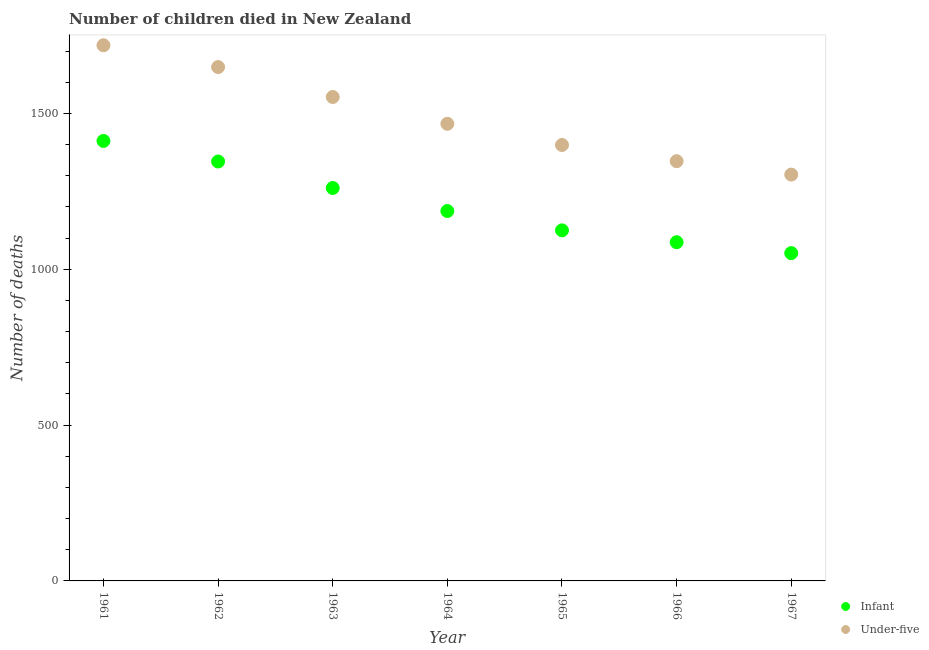How many different coloured dotlines are there?
Offer a very short reply. 2. What is the number of under-five deaths in 1964?
Your answer should be very brief. 1467. Across all years, what is the maximum number of under-five deaths?
Provide a short and direct response. 1719. Across all years, what is the minimum number of under-five deaths?
Your answer should be compact. 1304. In which year was the number of infant deaths maximum?
Give a very brief answer. 1961. In which year was the number of infant deaths minimum?
Offer a terse response. 1967. What is the total number of under-five deaths in the graph?
Give a very brief answer. 1.04e+04. What is the difference between the number of infant deaths in 1966 and that in 1967?
Your response must be concise. 35. What is the difference between the number of under-five deaths in 1967 and the number of infant deaths in 1961?
Your answer should be compact. -108. What is the average number of under-five deaths per year?
Your response must be concise. 1491.14. In the year 1967, what is the difference between the number of infant deaths and number of under-five deaths?
Your response must be concise. -252. What is the ratio of the number of under-five deaths in 1963 to that in 1966?
Provide a short and direct response. 1.15. Is the number of infant deaths in 1962 less than that in 1965?
Offer a very short reply. No. Is the difference between the number of infant deaths in 1964 and 1965 greater than the difference between the number of under-five deaths in 1964 and 1965?
Offer a terse response. No. What is the difference between the highest and the second highest number of infant deaths?
Make the answer very short. 66. What is the difference between the highest and the lowest number of under-five deaths?
Give a very brief answer. 415. Is the sum of the number of infant deaths in 1962 and 1963 greater than the maximum number of under-five deaths across all years?
Keep it short and to the point. Yes. Does the number of infant deaths monotonically increase over the years?
Ensure brevity in your answer.  No. Is the number of under-five deaths strictly less than the number of infant deaths over the years?
Keep it short and to the point. No. How many dotlines are there?
Your response must be concise. 2. How many years are there in the graph?
Ensure brevity in your answer.  7. What is the difference between two consecutive major ticks on the Y-axis?
Your response must be concise. 500. Are the values on the major ticks of Y-axis written in scientific E-notation?
Make the answer very short. No. Does the graph contain any zero values?
Ensure brevity in your answer.  No. How many legend labels are there?
Your response must be concise. 2. How are the legend labels stacked?
Offer a terse response. Vertical. What is the title of the graph?
Your answer should be very brief. Number of children died in New Zealand. What is the label or title of the Y-axis?
Your answer should be compact. Number of deaths. What is the Number of deaths of Infant in 1961?
Provide a short and direct response. 1412. What is the Number of deaths of Under-five in 1961?
Give a very brief answer. 1719. What is the Number of deaths of Infant in 1962?
Provide a succinct answer. 1346. What is the Number of deaths in Under-five in 1962?
Your answer should be very brief. 1649. What is the Number of deaths of Infant in 1963?
Your answer should be compact. 1261. What is the Number of deaths of Under-five in 1963?
Provide a succinct answer. 1553. What is the Number of deaths of Infant in 1964?
Keep it short and to the point. 1187. What is the Number of deaths in Under-five in 1964?
Give a very brief answer. 1467. What is the Number of deaths in Infant in 1965?
Provide a short and direct response. 1125. What is the Number of deaths in Under-five in 1965?
Give a very brief answer. 1399. What is the Number of deaths of Infant in 1966?
Keep it short and to the point. 1087. What is the Number of deaths of Under-five in 1966?
Keep it short and to the point. 1347. What is the Number of deaths of Infant in 1967?
Your answer should be very brief. 1052. What is the Number of deaths of Under-five in 1967?
Make the answer very short. 1304. Across all years, what is the maximum Number of deaths of Infant?
Provide a short and direct response. 1412. Across all years, what is the maximum Number of deaths of Under-five?
Your response must be concise. 1719. Across all years, what is the minimum Number of deaths in Infant?
Provide a short and direct response. 1052. Across all years, what is the minimum Number of deaths of Under-five?
Your answer should be very brief. 1304. What is the total Number of deaths of Infant in the graph?
Your answer should be very brief. 8470. What is the total Number of deaths in Under-five in the graph?
Your response must be concise. 1.04e+04. What is the difference between the Number of deaths of Infant in 1961 and that in 1962?
Make the answer very short. 66. What is the difference between the Number of deaths of Under-five in 1961 and that in 1962?
Your answer should be compact. 70. What is the difference between the Number of deaths in Infant in 1961 and that in 1963?
Provide a short and direct response. 151. What is the difference between the Number of deaths of Under-five in 1961 and that in 1963?
Give a very brief answer. 166. What is the difference between the Number of deaths in Infant in 1961 and that in 1964?
Offer a very short reply. 225. What is the difference between the Number of deaths in Under-five in 1961 and that in 1964?
Your answer should be very brief. 252. What is the difference between the Number of deaths in Infant in 1961 and that in 1965?
Your answer should be very brief. 287. What is the difference between the Number of deaths in Under-five in 1961 and that in 1965?
Provide a succinct answer. 320. What is the difference between the Number of deaths in Infant in 1961 and that in 1966?
Offer a very short reply. 325. What is the difference between the Number of deaths of Under-five in 1961 and that in 1966?
Keep it short and to the point. 372. What is the difference between the Number of deaths of Infant in 1961 and that in 1967?
Provide a succinct answer. 360. What is the difference between the Number of deaths of Under-five in 1961 and that in 1967?
Offer a terse response. 415. What is the difference between the Number of deaths of Under-five in 1962 and that in 1963?
Offer a very short reply. 96. What is the difference between the Number of deaths in Infant in 1962 and that in 1964?
Your answer should be very brief. 159. What is the difference between the Number of deaths in Under-five in 1962 and that in 1964?
Provide a succinct answer. 182. What is the difference between the Number of deaths in Infant in 1962 and that in 1965?
Ensure brevity in your answer.  221. What is the difference between the Number of deaths in Under-five in 1962 and that in 1965?
Provide a succinct answer. 250. What is the difference between the Number of deaths of Infant in 1962 and that in 1966?
Ensure brevity in your answer.  259. What is the difference between the Number of deaths of Under-five in 1962 and that in 1966?
Keep it short and to the point. 302. What is the difference between the Number of deaths of Infant in 1962 and that in 1967?
Keep it short and to the point. 294. What is the difference between the Number of deaths in Under-five in 1962 and that in 1967?
Keep it short and to the point. 345. What is the difference between the Number of deaths of Infant in 1963 and that in 1964?
Provide a succinct answer. 74. What is the difference between the Number of deaths of Under-five in 1963 and that in 1964?
Your response must be concise. 86. What is the difference between the Number of deaths in Infant in 1963 and that in 1965?
Keep it short and to the point. 136. What is the difference between the Number of deaths of Under-five in 1963 and that in 1965?
Ensure brevity in your answer.  154. What is the difference between the Number of deaths in Infant in 1963 and that in 1966?
Keep it short and to the point. 174. What is the difference between the Number of deaths in Under-five in 1963 and that in 1966?
Your response must be concise. 206. What is the difference between the Number of deaths in Infant in 1963 and that in 1967?
Ensure brevity in your answer.  209. What is the difference between the Number of deaths in Under-five in 1963 and that in 1967?
Offer a very short reply. 249. What is the difference between the Number of deaths in Infant in 1964 and that in 1965?
Provide a succinct answer. 62. What is the difference between the Number of deaths in Under-five in 1964 and that in 1966?
Give a very brief answer. 120. What is the difference between the Number of deaths in Infant in 1964 and that in 1967?
Your answer should be very brief. 135. What is the difference between the Number of deaths in Under-five in 1964 and that in 1967?
Offer a very short reply. 163. What is the difference between the Number of deaths of Infant in 1965 and that in 1966?
Your answer should be very brief. 38. What is the difference between the Number of deaths of Under-five in 1965 and that in 1966?
Your answer should be compact. 52. What is the difference between the Number of deaths in Infant in 1965 and that in 1967?
Make the answer very short. 73. What is the difference between the Number of deaths of Under-five in 1965 and that in 1967?
Make the answer very short. 95. What is the difference between the Number of deaths in Infant in 1966 and that in 1967?
Your answer should be compact. 35. What is the difference between the Number of deaths in Under-five in 1966 and that in 1967?
Your answer should be compact. 43. What is the difference between the Number of deaths in Infant in 1961 and the Number of deaths in Under-five in 1962?
Your response must be concise. -237. What is the difference between the Number of deaths of Infant in 1961 and the Number of deaths of Under-five in 1963?
Your answer should be compact. -141. What is the difference between the Number of deaths in Infant in 1961 and the Number of deaths in Under-five in 1964?
Give a very brief answer. -55. What is the difference between the Number of deaths in Infant in 1961 and the Number of deaths in Under-five in 1965?
Make the answer very short. 13. What is the difference between the Number of deaths of Infant in 1961 and the Number of deaths of Under-five in 1967?
Offer a very short reply. 108. What is the difference between the Number of deaths in Infant in 1962 and the Number of deaths in Under-five in 1963?
Offer a very short reply. -207. What is the difference between the Number of deaths of Infant in 1962 and the Number of deaths of Under-five in 1964?
Your answer should be compact. -121. What is the difference between the Number of deaths in Infant in 1962 and the Number of deaths in Under-five in 1965?
Provide a short and direct response. -53. What is the difference between the Number of deaths in Infant in 1963 and the Number of deaths in Under-five in 1964?
Ensure brevity in your answer.  -206. What is the difference between the Number of deaths of Infant in 1963 and the Number of deaths of Under-five in 1965?
Your answer should be compact. -138. What is the difference between the Number of deaths in Infant in 1963 and the Number of deaths in Under-five in 1966?
Your response must be concise. -86. What is the difference between the Number of deaths in Infant in 1963 and the Number of deaths in Under-five in 1967?
Your answer should be very brief. -43. What is the difference between the Number of deaths of Infant in 1964 and the Number of deaths of Under-five in 1965?
Your response must be concise. -212. What is the difference between the Number of deaths in Infant in 1964 and the Number of deaths in Under-five in 1966?
Offer a very short reply. -160. What is the difference between the Number of deaths of Infant in 1964 and the Number of deaths of Under-five in 1967?
Make the answer very short. -117. What is the difference between the Number of deaths in Infant in 1965 and the Number of deaths in Under-five in 1966?
Offer a very short reply. -222. What is the difference between the Number of deaths in Infant in 1965 and the Number of deaths in Under-five in 1967?
Your answer should be compact. -179. What is the difference between the Number of deaths in Infant in 1966 and the Number of deaths in Under-five in 1967?
Provide a succinct answer. -217. What is the average Number of deaths in Infant per year?
Offer a very short reply. 1210. What is the average Number of deaths in Under-five per year?
Keep it short and to the point. 1491.14. In the year 1961, what is the difference between the Number of deaths of Infant and Number of deaths of Under-five?
Offer a very short reply. -307. In the year 1962, what is the difference between the Number of deaths of Infant and Number of deaths of Under-five?
Your answer should be very brief. -303. In the year 1963, what is the difference between the Number of deaths of Infant and Number of deaths of Under-five?
Provide a short and direct response. -292. In the year 1964, what is the difference between the Number of deaths in Infant and Number of deaths in Under-five?
Make the answer very short. -280. In the year 1965, what is the difference between the Number of deaths in Infant and Number of deaths in Under-five?
Ensure brevity in your answer.  -274. In the year 1966, what is the difference between the Number of deaths in Infant and Number of deaths in Under-five?
Give a very brief answer. -260. In the year 1967, what is the difference between the Number of deaths in Infant and Number of deaths in Under-five?
Make the answer very short. -252. What is the ratio of the Number of deaths in Infant in 1961 to that in 1962?
Your response must be concise. 1.05. What is the ratio of the Number of deaths of Under-five in 1961 to that in 1962?
Ensure brevity in your answer.  1.04. What is the ratio of the Number of deaths of Infant in 1961 to that in 1963?
Ensure brevity in your answer.  1.12. What is the ratio of the Number of deaths in Under-five in 1961 to that in 1963?
Offer a terse response. 1.11. What is the ratio of the Number of deaths in Infant in 1961 to that in 1964?
Ensure brevity in your answer.  1.19. What is the ratio of the Number of deaths in Under-five in 1961 to that in 1964?
Keep it short and to the point. 1.17. What is the ratio of the Number of deaths of Infant in 1961 to that in 1965?
Give a very brief answer. 1.26. What is the ratio of the Number of deaths in Under-five in 1961 to that in 1965?
Your answer should be compact. 1.23. What is the ratio of the Number of deaths in Infant in 1961 to that in 1966?
Offer a terse response. 1.3. What is the ratio of the Number of deaths in Under-five in 1961 to that in 1966?
Offer a terse response. 1.28. What is the ratio of the Number of deaths of Infant in 1961 to that in 1967?
Provide a short and direct response. 1.34. What is the ratio of the Number of deaths of Under-five in 1961 to that in 1967?
Your answer should be very brief. 1.32. What is the ratio of the Number of deaths in Infant in 1962 to that in 1963?
Your answer should be compact. 1.07. What is the ratio of the Number of deaths of Under-five in 1962 to that in 1963?
Provide a short and direct response. 1.06. What is the ratio of the Number of deaths of Infant in 1962 to that in 1964?
Keep it short and to the point. 1.13. What is the ratio of the Number of deaths of Under-five in 1962 to that in 1964?
Offer a terse response. 1.12. What is the ratio of the Number of deaths of Infant in 1962 to that in 1965?
Ensure brevity in your answer.  1.2. What is the ratio of the Number of deaths in Under-five in 1962 to that in 1965?
Your answer should be very brief. 1.18. What is the ratio of the Number of deaths in Infant in 1962 to that in 1966?
Make the answer very short. 1.24. What is the ratio of the Number of deaths of Under-five in 1962 to that in 1966?
Make the answer very short. 1.22. What is the ratio of the Number of deaths of Infant in 1962 to that in 1967?
Keep it short and to the point. 1.28. What is the ratio of the Number of deaths of Under-five in 1962 to that in 1967?
Your response must be concise. 1.26. What is the ratio of the Number of deaths in Infant in 1963 to that in 1964?
Give a very brief answer. 1.06. What is the ratio of the Number of deaths in Under-five in 1963 to that in 1964?
Offer a terse response. 1.06. What is the ratio of the Number of deaths in Infant in 1963 to that in 1965?
Offer a very short reply. 1.12. What is the ratio of the Number of deaths of Under-five in 1963 to that in 1965?
Provide a short and direct response. 1.11. What is the ratio of the Number of deaths of Infant in 1963 to that in 1966?
Provide a succinct answer. 1.16. What is the ratio of the Number of deaths in Under-five in 1963 to that in 1966?
Offer a terse response. 1.15. What is the ratio of the Number of deaths of Infant in 1963 to that in 1967?
Offer a very short reply. 1.2. What is the ratio of the Number of deaths in Under-five in 1963 to that in 1967?
Offer a very short reply. 1.19. What is the ratio of the Number of deaths in Infant in 1964 to that in 1965?
Your response must be concise. 1.06. What is the ratio of the Number of deaths in Under-five in 1964 to that in 1965?
Offer a terse response. 1.05. What is the ratio of the Number of deaths in Infant in 1964 to that in 1966?
Offer a terse response. 1.09. What is the ratio of the Number of deaths in Under-five in 1964 to that in 1966?
Ensure brevity in your answer.  1.09. What is the ratio of the Number of deaths of Infant in 1964 to that in 1967?
Your response must be concise. 1.13. What is the ratio of the Number of deaths in Under-five in 1964 to that in 1967?
Your answer should be very brief. 1.12. What is the ratio of the Number of deaths in Infant in 1965 to that in 1966?
Keep it short and to the point. 1.03. What is the ratio of the Number of deaths of Under-five in 1965 to that in 1966?
Your answer should be compact. 1.04. What is the ratio of the Number of deaths in Infant in 1965 to that in 1967?
Offer a terse response. 1.07. What is the ratio of the Number of deaths in Under-five in 1965 to that in 1967?
Your answer should be very brief. 1.07. What is the ratio of the Number of deaths of Infant in 1966 to that in 1967?
Provide a succinct answer. 1.03. What is the ratio of the Number of deaths of Under-five in 1966 to that in 1967?
Offer a terse response. 1.03. What is the difference between the highest and the second highest Number of deaths of Infant?
Your answer should be compact. 66. What is the difference between the highest and the second highest Number of deaths of Under-five?
Offer a very short reply. 70. What is the difference between the highest and the lowest Number of deaths of Infant?
Provide a succinct answer. 360. What is the difference between the highest and the lowest Number of deaths of Under-five?
Keep it short and to the point. 415. 